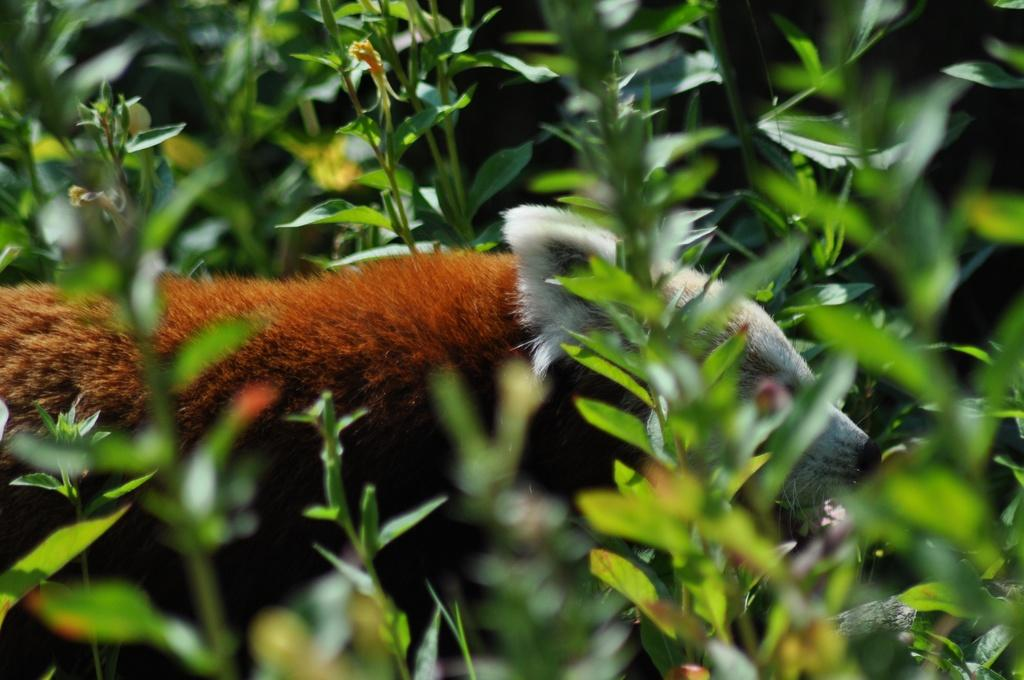What type of animal is in the image? There is a red panda in the image. What is surrounding the red panda in the image? There are plants surrounding the red panda in the image. What direction is the red panda facing in the image? The direction the red panda is facing cannot be determined from the image. What type of rock is visible in the image? There is no rock visible in the image. Is there a flame present in the image? There is no flame present in the image. 